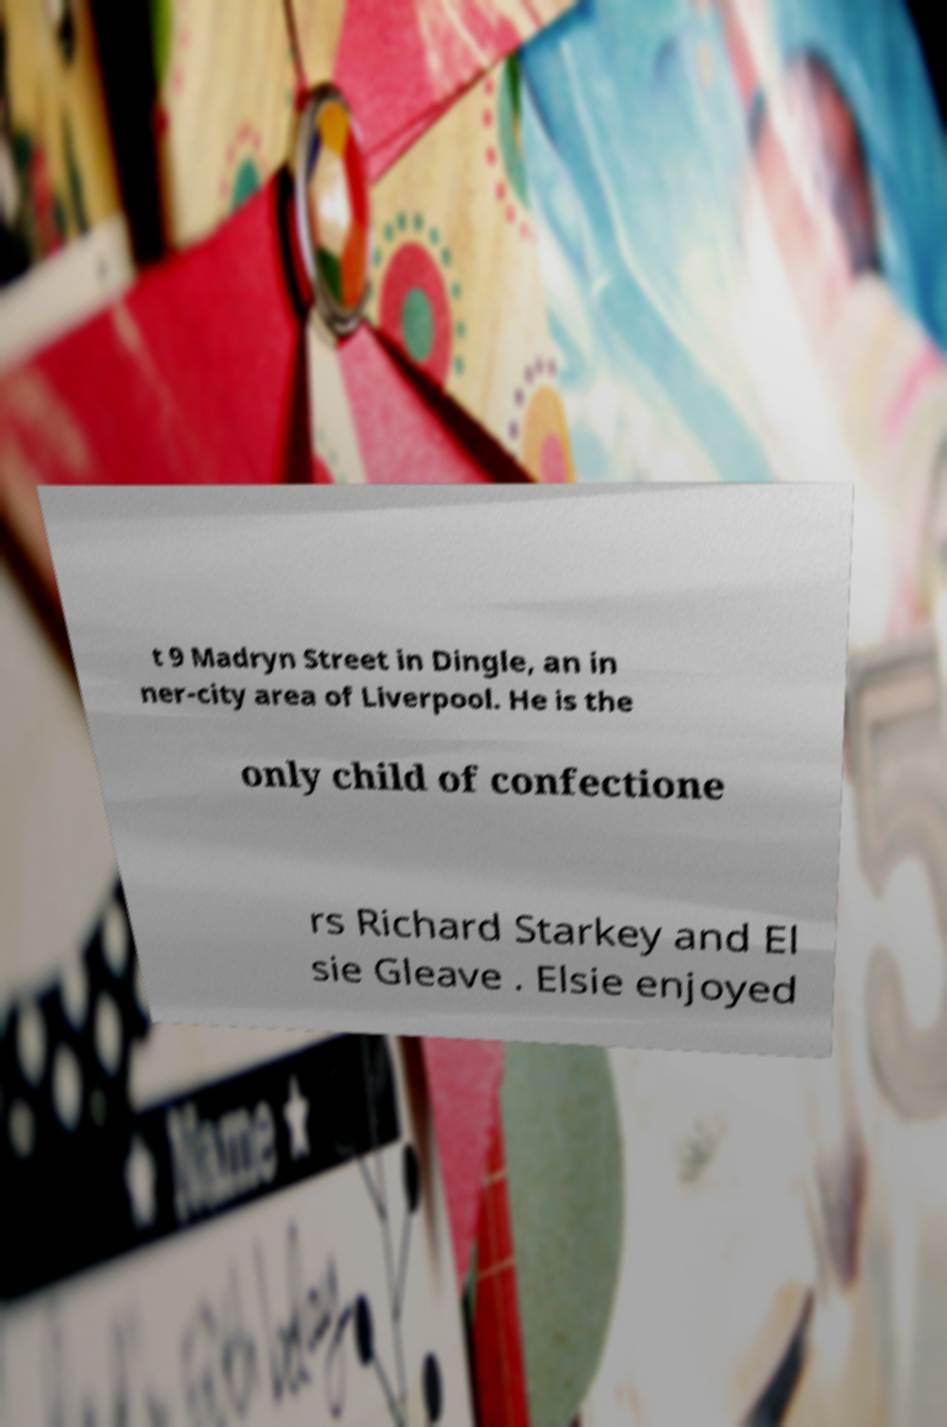There's text embedded in this image that I need extracted. Can you transcribe it verbatim? t 9 Madryn Street in Dingle, an in ner-city area of Liverpool. He is the only child of confectione rs Richard Starkey and El sie Gleave . Elsie enjoyed 